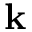Convert formula to latex. <formula><loc_0><loc_0><loc_500><loc_500>k</formula> 